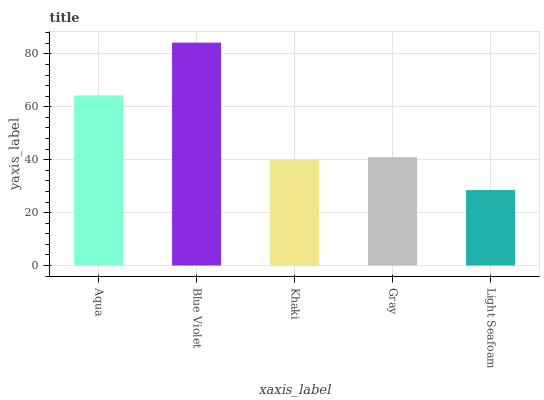Is Light Seafoam the minimum?
Answer yes or no. Yes. Is Blue Violet the maximum?
Answer yes or no. Yes. Is Khaki the minimum?
Answer yes or no. No. Is Khaki the maximum?
Answer yes or no. No. Is Blue Violet greater than Khaki?
Answer yes or no. Yes. Is Khaki less than Blue Violet?
Answer yes or no. Yes. Is Khaki greater than Blue Violet?
Answer yes or no. No. Is Blue Violet less than Khaki?
Answer yes or no. No. Is Gray the high median?
Answer yes or no. Yes. Is Gray the low median?
Answer yes or no. Yes. Is Aqua the high median?
Answer yes or no. No. Is Khaki the low median?
Answer yes or no. No. 